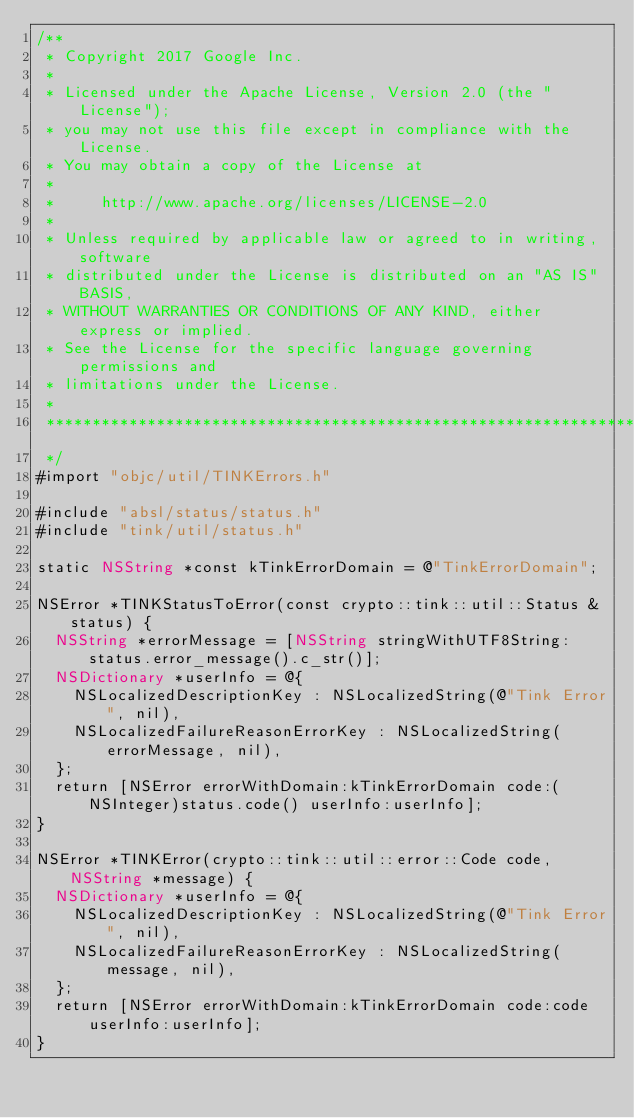<code> <loc_0><loc_0><loc_500><loc_500><_ObjectiveC_>/**
 * Copyright 2017 Google Inc.
 *
 * Licensed under the Apache License, Version 2.0 (the "License");
 * you may not use this file except in compliance with the License.
 * You may obtain a copy of the License at
 *
 *     http://www.apache.org/licenses/LICENSE-2.0
 *
 * Unless required by applicable law or agreed to in writing, software
 * distributed under the License is distributed on an "AS IS" BASIS,
 * WITHOUT WARRANTIES OR CONDITIONS OF ANY KIND, either express or implied.
 * See the License for the specific language governing permissions and
 * limitations under the License.
 *
 **************************************************************************
 */
#import "objc/util/TINKErrors.h"

#include "absl/status/status.h"
#include "tink/util/status.h"

static NSString *const kTinkErrorDomain = @"TinkErrorDomain";

NSError *TINKStatusToError(const crypto::tink::util::Status &status) {
  NSString *errorMessage = [NSString stringWithUTF8String:status.error_message().c_str()];
  NSDictionary *userInfo = @{
    NSLocalizedDescriptionKey : NSLocalizedString(@"Tink Error", nil),
    NSLocalizedFailureReasonErrorKey : NSLocalizedString(errorMessage, nil),
  };
  return [NSError errorWithDomain:kTinkErrorDomain code:(NSInteger)status.code() userInfo:userInfo];
}

NSError *TINKError(crypto::tink::util::error::Code code, NSString *message) {
  NSDictionary *userInfo = @{
    NSLocalizedDescriptionKey : NSLocalizedString(@"Tink Error", nil),
    NSLocalizedFailureReasonErrorKey : NSLocalizedString(message, nil),
  };
  return [NSError errorWithDomain:kTinkErrorDomain code:code userInfo:userInfo];
}
</code> 